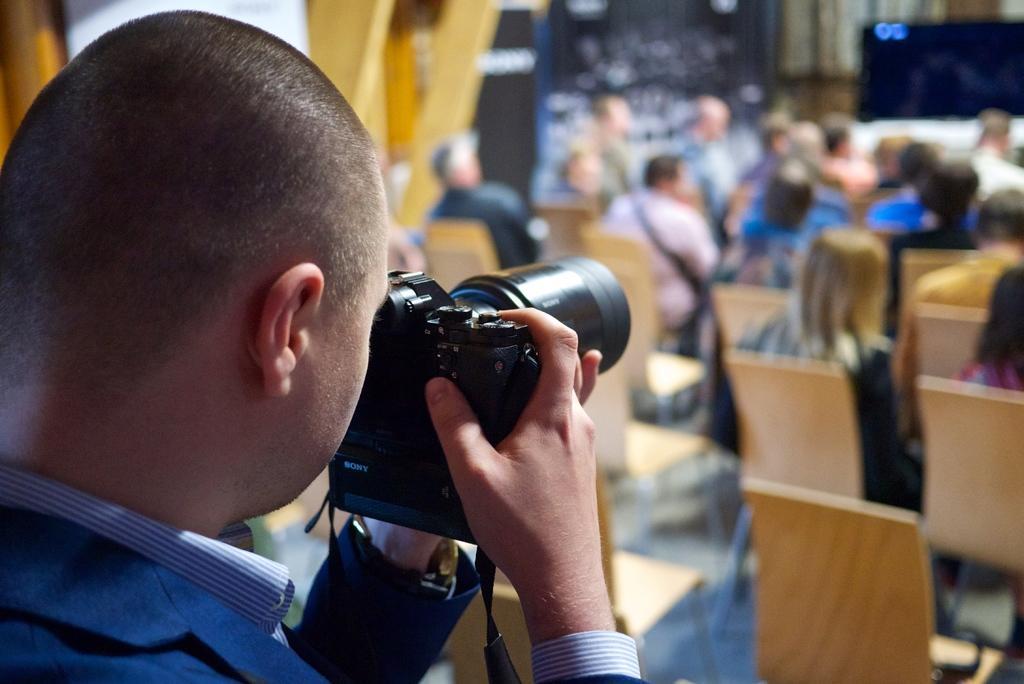Please provide a concise description of this image. There is a person on the left side and he is clicking an image with this camera. Here we can see a few people who are sitting on a chair. 